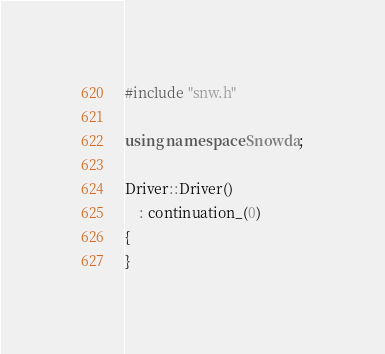<code> <loc_0><loc_0><loc_500><loc_500><_C++_>#include "snw.h"

using namespace Snowda;

Driver::Driver()
    : continuation_(0)
{
}
</code> 